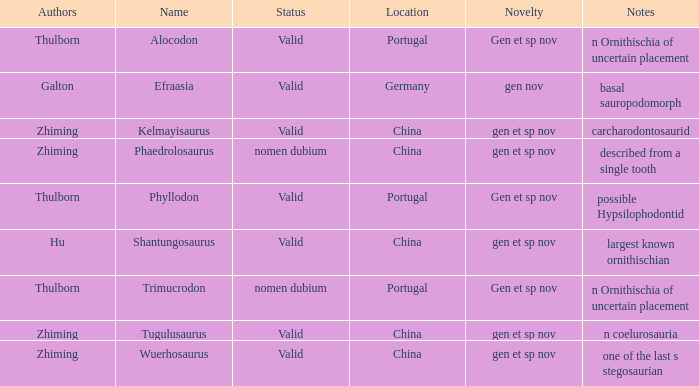What is the Novelty of the dinosaur, whose naming Author was Galton? Gen nov. I'm looking to parse the entire table for insights. Could you assist me with that? {'header': ['Authors', 'Name', 'Status', 'Location', 'Novelty', 'Notes'], 'rows': [['Thulborn', 'Alocodon', 'Valid', 'Portugal', 'Gen et sp nov', 'n Ornithischia of uncertain placement'], ['Galton', 'Efraasia', 'Valid', 'Germany', 'gen nov', 'basal sauropodomorph'], ['Zhiming', 'Kelmayisaurus', 'Valid', 'China', 'gen et sp nov', 'carcharodontosaurid'], ['Zhiming', 'Phaedrolosaurus', 'nomen dubium', 'China', 'gen et sp nov', 'described from a single tooth'], ['Thulborn', 'Phyllodon', 'Valid', 'Portugal', 'Gen et sp nov', 'possible Hypsilophodontid'], ['Hu', 'Shantungosaurus', 'Valid', 'China', 'gen et sp nov', 'largest known ornithischian'], ['Thulborn', 'Trimucrodon', 'nomen dubium', 'Portugal', 'Gen et sp nov', 'n Ornithischia of uncertain placement'], ['Zhiming', 'Tugulusaurus', 'Valid', 'China', 'gen et sp nov', 'n coelurosauria'], ['Zhiming', 'Wuerhosaurus', 'Valid', 'China', 'gen et sp nov', 'one of the last s stegosaurian']]} 